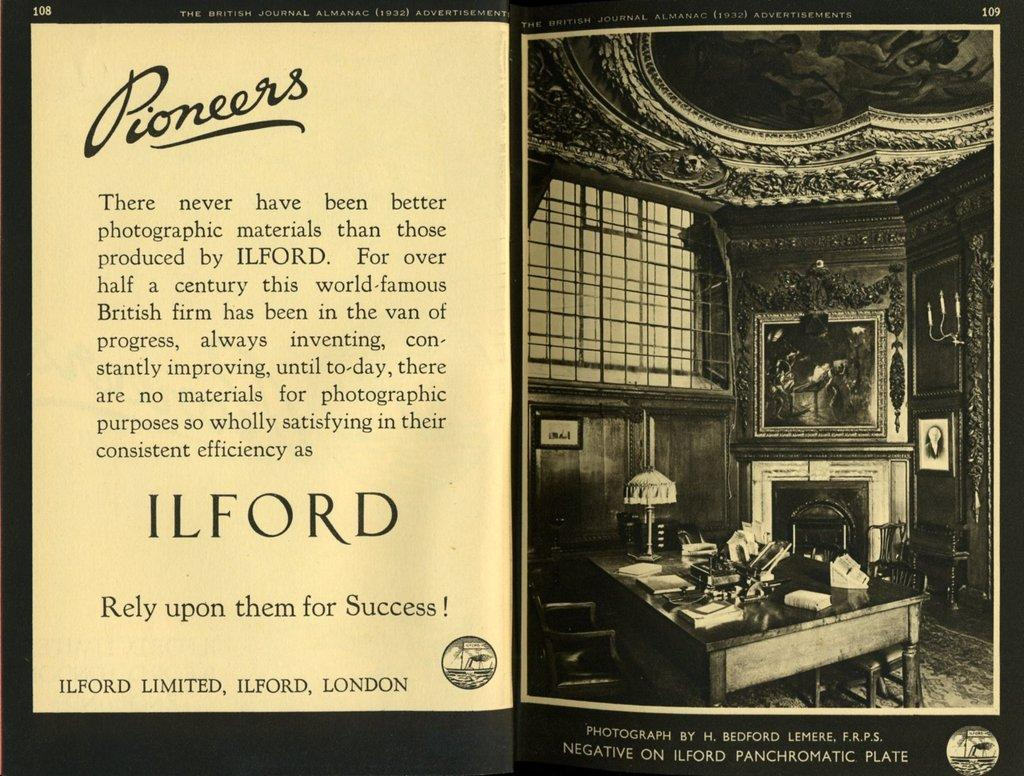<image>
Create a compact narrative representing the image presented. A black an white advertisement says that we can rely on Ilford for success. 